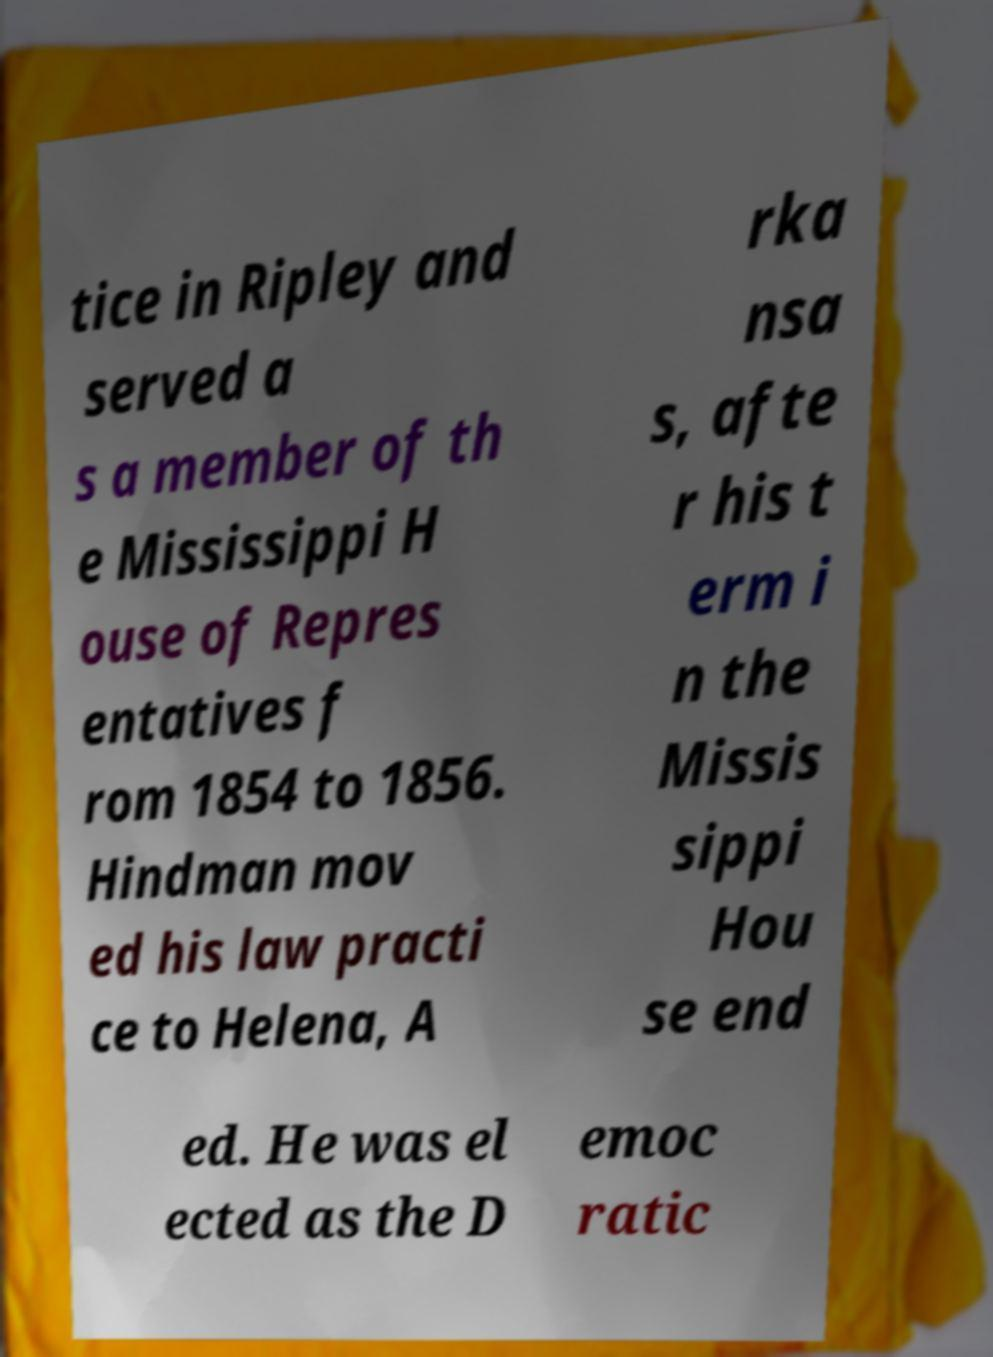Could you extract and type out the text from this image? tice in Ripley and served a s a member of th e Mississippi H ouse of Repres entatives f rom 1854 to 1856. Hindman mov ed his law practi ce to Helena, A rka nsa s, afte r his t erm i n the Missis sippi Hou se end ed. He was el ected as the D emoc ratic 